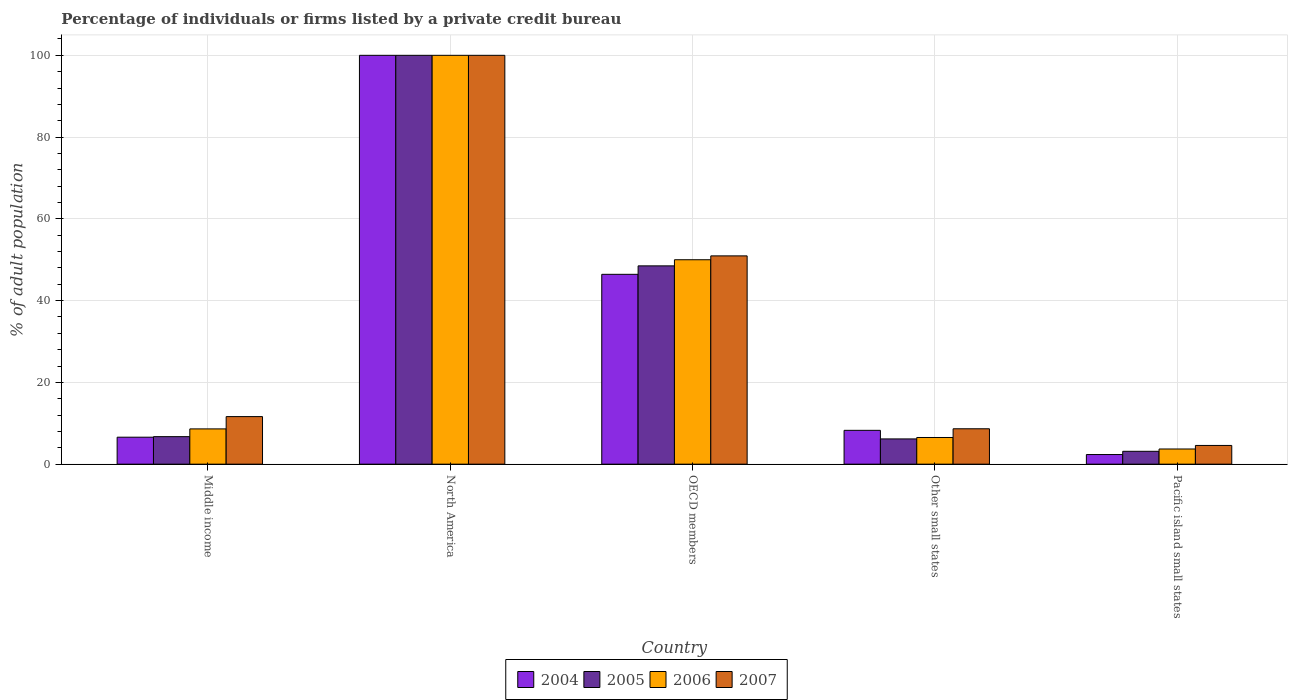How many bars are there on the 3rd tick from the right?
Provide a succinct answer. 4. What is the percentage of population listed by a private credit bureau in 2007 in OECD members?
Make the answer very short. 50.95. Across all countries, what is the maximum percentage of population listed by a private credit bureau in 2006?
Provide a succinct answer. 100. Across all countries, what is the minimum percentage of population listed by a private credit bureau in 2006?
Your answer should be compact. 3.71. In which country was the percentage of population listed by a private credit bureau in 2005 minimum?
Offer a terse response. Pacific island small states. What is the total percentage of population listed by a private credit bureau in 2004 in the graph?
Offer a very short reply. 163.66. What is the difference between the percentage of population listed by a private credit bureau in 2007 in OECD members and that in Other small states?
Your response must be concise. 42.29. What is the difference between the percentage of population listed by a private credit bureau in 2004 in Middle income and the percentage of population listed by a private credit bureau in 2007 in Other small states?
Provide a succinct answer. -2.06. What is the average percentage of population listed by a private credit bureau in 2005 per country?
Offer a very short reply. 32.91. What is the difference between the percentage of population listed by a private credit bureau of/in 2007 and percentage of population listed by a private credit bureau of/in 2004 in Pacific island small states?
Your answer should be very brief. 2.22. In how many countries, is the percentage of population listed by a private credit bureau in 2005 greater than 100 %?
Your answer should be very brief. 0. What is the ratio of the percentage of population listed by a private credit bureau in 2007 in Middle income to that in OECD members?
Provide a succinct answer. 0.23. Is the difference between the percentage of population listed by a private credit bureau in 2007 in North America and OECD members greater than the difference between the percentage of population listed by a private credit bureau in 2004 in North America and OECD members?
Your response must be concise. No. What is the difference between the highest and the second highest percentage of population listed by a private credit bureau in 2006?
Offer a terse response. -41.38. What is the difference between the highest and the lowest percentage of population listed by a private credit bureau in 2005?
Keep it short and to the point. 96.86. In how many countries, is the percentage of population listed by a private credit bureau in 2006 greater than the average percentage of population listed by a private credit bureau in 2006 taken over all countries?
Your answer should be compact. 2. How many countries are there in the graph?
Your answer should be compact. 5. What is the difference between two consecutive major ticks on the Y-axis?
Your response must be concise. 20. Where does the legend appear in the graph?
Your answer should be compact. Bottom center. What is the title of the graph?
Your answer should be compact. Percentage of individuals or firms listed by a private credit bureau. Does "2000" appear as one of the legend labels in the graph?
Provide a succinct answer. No. What is the label or title of the Y-axis?
Your answer should be very brief. % of adult population. What is the % of adult population in 2004 in Middle income?
Offer a terse response. 6.6. What is the % of adult population in 2005 in Middle income?
Offer a very short reply. 6.73. What is the % of adult population in 2006 in Middle income?
Keep it short and to the point. 8.62. What is the % of adult population of 2007 in Middle income?
Your answer should be very brief. 11.63. What is the % of adult population of 2004 in North America?
Your response must be concise. 100. What is the % of adult population of 2005 in North America?
Offer a terse response. 100. What is the % of adult population in 2007 in North America?
Provide a succinct answer. 100. What is the % of adult population of 2004 in OECD members?
Offer a terse response. 46.43. What is the % of adult population of 2005 in OECD members?
Offer a very short reply. 48.5. What is the % of adult population in 2007 in OECD members?
Provide a succinct answer. 50.95. What is the % of adult population of 2004 in Other small states?
Provide a short and direct response. 8.28. What is the % of adult population of 2005 in Other small states?
Give a very brief answer. 6.18. What is the % of adult population of 2006 in Other small states?
Ensure brevity in your answer.  6.52. What is the % of adult population of 2007 in Other small states?
Keep it short and to the point. 8.66. What is the % of adult population of 2004 in Pacific island small states?
Give a very brief answer. 2.36. What is the % of adult population of 2005 in Pacific island small states?
Give a very brief answer. 3.14. What is the % of adult population of 2006 in Pacific island small states?
Your answer should be very brief. 3.71. What is the % of adult population in 2007 in Pacific island small states?
Keep it short and to the point. 4.58. Across all countries, what is the maximum % of adult population of 2004?
Your answer should be very brief. 100. Across all countries, what is the maximum % of adult population of 2005?
Make the answer very short. 100. Across all countries, what is the minimum % of adult population in 2004?
Your response must be concise. 2.36. Across all countries, what is the minimum % of adult population of 2005?
Your answer should be compact. 3.14. Across all countries, what is the minimum % of adult population in 2006?
Your answer should be compact. 3.71. Across all countries, what is the minimum % of adult population of 2007?
Your answer should be very brief. 4.58. What is the total % of adult population of 2004 in the graph?
Your response must be concise. 163.66. What is the total % of adult population in 2005 in the graph?
Offer a very short reply. 164.55. What is the total % of adult population in 2006 in the graph?
Keep it short and to the point. 168.86. What is the total % of adult population of 2007 in the graph?
Your answer should be very brief. 175.81. What is the difference between the % of adult population in 2004 in Middle income and that in North America?
Make the answer very short. -93.4. What is the difference between the % of adult population in 2005 in Middle income and that in North America?
Provide a short and direct response. -93.27. What is the difference between the % of adult population of 2006 in Middle income and that in North America?
Your answer should be very brief. -91.38. What is the difference between the % of adult population in 2007 in Middle income and that in North America?
Make the answer very short. -88.37. What is the difference between the % of adult population in 2004 in Middle income and that in OECD members?
Give a very brief answer. -39.84. What is the difference between the % of adult population in 2005 in Middle income and that in OECD members?
Keep it short and to the point. -41.77. What is the difference between the % of adult population in 2006 in Middle income and that in OECD members?
Provide a short and direct response. -41.38. What is the difference between the % of adult population of 2007 in Middle income and that in OECD members?
Make the answer very short. -39.31. What is the difference between the % of adult population in 2004 in Middle income and that in Other small states?
Your answer should be very brief. -1.68. What is the difference between the % of adult population of 2005 in Middle income and that in Other small states?
Make the answer very short. 0.55. What is the difference between the % of adult population of 2006 in Middle income and that in Other small states?
Keep it short and to the point. 2.1. What is the difference between the % of adult population in 2007 in Middle income and that in Other small states?
Offer a terse response. 2.98. What is the difference between the % of adult population in 2004 in Middle income and that in Pacific island small states?
Provide a short and direct response. 4.24. What is the difference between the % of adult population of 2005 in Middle income and that in Pacific island small states?
Provide a succinct answer. 3.58. What is the difference between the % of adult population of 2006 in Middle income and that in Pacific island small states?
Offer a terse response. 4.91. What is the difference between the % of adult population in 2007 in Middle income and that in Pacific island small states?
Offer a terse response. 7.06. What is the difference between the % of adult population of 2004 in North America and that in OECD members?
Provide a short and direct response. 53.57. What is the difference between the % of adult population of 2005 in North America and that in OECD members?
Make the answer very short. 51.5. What is the difference between the % of adult population in 2006 in North America and that in OECD members?
Offer a terse response. 50. What is the difference between the % of adult population in 2007 in North America and that in OECD members?
Keep it short and to the point. 49.05. What is the difference between the % of adult population in 2004 in North America and that in Other small states?
Give a very brief answer. 91.72. What is the difference between the % of adult population in 2005 in North America and that in Other small states?
Offer a terse response. 93.82. What is the difference between the % of adult population of 2006 in North America and that in Other small states?
Ensure brevity in your answer.  93.48. What is the difference between the % of adult population of 2007 in North America and that in Other small states?
Ensure brevity in your answer.  91.34. What is the difference between the % of adult population of 2004 in North America and that in Pacific island small states?
Make the answer very short. 97.64. What is the difference between the % of adult population of 2005 in North America and that in Pacific island small states?
Your answer should be compact. 96.86. What is the difference between the % of adult population in 2006 in North America and that in Pacific island small states?
Your answer should be compact. 96.29. What is the difference between the % of adult population of 2007 in North America and that in Pacific island small states?
Make the answer very short. 95.42. What is the difference between the % of adult population in 2004 in OECD members and that in Other small states?
Your answer should be very brief. 38.16. What is the difference between the % of adult population in 2005 in OECD members and that in Other small states?
Your response must be concise. 42.33. What is the difference between the % of adult population of 2006 in OECD members and that in Other small states?
Offer a terse response. 43.48. What is the difference between the % of adult population of 2007 in OECD members and that in Other small states?
Your answer should be compact. 42.29. What is the difference between the % of adult population of 2004 in OECD members and that in Pacific island small states?
Offer a terse response. 44.08. What is the difference between the % of adult population of 2005 in OECD members and that in Pacific island small states?
Your answer should be compact. 45.36. What is the difference between the % of adult population of 2006 in OECD members and that in Pacific island small states?
Ensure brevity in your answer.  46.29. What is the difference between the % of adult population in 2007 in OECD members and that in Pacific island small states?
Keep it short and to the point. 46.37. What is the difference between the % of adult population in 2004 in Other small states and that in Pacific island small states?
Provide a succinct answer. 5.92. What is the difference between the % of adult population in 2005 in Other small states and that in Pacific island small states?
Keep it short and to the point. 3.03. What is the difference between the % of adult population of 2006 in Other small states and that in Pacific island small states?
Provide a succinct answer. 2.81. What is the difference between the % of adult population in 2007 in Other small states and that in Pacific island small states?
Make the answer very short. 4.08. What is the difference between the % of adult population of 2004 in Middle income and the % of adult population of 2005 in North America?
Make the answer very short. -93.4. What is the difference between the % of adult population of 2004 in Middle income and the % of adult population of 2006 in North America?
Provide a short and direct response. -93.4. What is the difference between the % of adult population of 2004 in Middle income and the % of adult population of 2007 in North America?
Your answer should be compact. -93.4. What is the difference between the % of adult population in 2005 in Middle income and the % of adult population in 2006 in North America?
Provide a succinct answer. -93.27. What is the difference between the % of adult population of 2005 in Middle income and the % of adult population of 2007 in North America?
Your answer should be very brief. -93.27. What is the difference between the % of adult population in 2006 in Middle income and the % of adult population in 2007 in North America?
Provide a succinct answer. -91.38. What is the difference between the % of adult population in 2004 in Middle income and the % of adult population in 2005 in OECD members?
Your answer should be very brief. -41.91. What is the difference between the % of adult population in 2004 in Middle income and the % of adult population in 2006 in OECD members?
Keep it short and to the point. -43.4. What is the difference between the % of adult population of 2004 in Middle income and the % of adult population of 2007 in OECD members?
Your answer should be very brief. -44.35. What is the difference between the % of adult population of 2005 in Middle income and the % of adult population of 2006 in OECD members?
Keep it short and to the point. -43.27. What is the difference between the % of adult population in 2005 in Middle income and the % of adult population in 2007 in OECD members?
Provide a short and direct response. -44.22. What is the difference between the % of adult population in 2006 in Middle income and the % of adult population in 2007 in OECD members?
Your response must be concise. -42.32. What is the difference between the % of adult population in 2004 in Middle income and the % of adult population in 2005 in Other small states?
Provide a succinct answer. 0.42. What is the difference between the % of adult population of 2004 in Middle income and the % of adult population of 2006 in Other small states?
Offer a terse response. 0.07. What is the difference between the % of adult population of 2004 in Middle income and the % of adult population of 2007 in Other small states?
Provide a short and direct response. -2.06. What is the difference between the % of adult population of 2005 in Middle income and the % of adult population of 2006 in Other small states?
Ensure brevity in your answer.  0.21. What is the difference between the % of adult population of 2005 in Middle income and the % of adult population of 2007 in Other small states?
Your answer should be compact. -1.93. What is the difference between the % of adult population of 2006 in Middle income and the % of adult population of 2007 in Other small states?
Offer a very short reply. -0.03. What is the difference between the % of adult population of 2004 in Middle income and the % of adult population of 2005 in Pacific island small states?
Your response must be concise. 3.45. What is the difference between the % of adult population in 2004 in Middle income and the % of adult population in 2006 in Pacific island small states?
Provide a succinct answer. 2.88. What is the difference between the % of adult population in 2004 in Middle income and the % of adult population in 2007 in Pacific island small states?
Provide a succinct answer. 2.02. What is the difference between the % of adult population in 2005 in Middle income and the % of adult population in 2006 in Pacific island small states?
Offer a terse response. 3.02. What is the difference between the % of adult population of 2005 in Middle income and the % of adult population of 2007 in Pacific island small states?
Provide a short and direct response. 2.15. What is the difference between the % of adult population in 2006 in Middle income and the % of adult population in 2007 in Pacific island small states?
Give a very brief answer. 4.05. What is the difference between the % of adult population of 2004 in North America and the % of adult population of 2005 in OECD members?
Your answer should be compact. 51.5. What is the difference between the % of adult population in 2004 in North America and the % of adult population in 2006 in OECD members?
Your answer should be compact. 50. What is the difference between the % of adult population of 2004 in North America and the % of adult population of 2007 in OECD members?
Provide a succinct answer. 49.05. What is the difference between the % of adult population in 2005 in North America and the % of adult population in 2006 in OECD members?
Make the answer very short. 50. What is the difference between the % of adult population of 2005 in North America and the % of adult population of 2007 in OECD members?
Your response must be concise. 49.05. What is the difference between the % of adult population in 2006 in North America and the % of adult population in 2007 in OECD members?
Ensure brevity in your answer.  49.05. What is the difference between the % of adult population in 2004 in North America and the % of adult population in 2005 in Other small states?
Provide a short and direct response. 93.82. What is the difference between the % of adult population of 2004 in North America and the % of adult population of 2006 in Other small states?
Offer a terse response. 93.48. What is the difference between the % of adult population in 2004 in North America and the % of adult population in 2007 in Other small states?
Your answer should be very brief. 91.34. What is the difference between the % of adult population in 2005 in North America and the % of adult population in 2006 in Other small states?
Keep it short and to the point. 93.48. What is the difference between the % of adult population in 2005 in North America and the % of adult population in 2007 in Other small states?
Keep it short and to the point. 91.34. What is the difference between the % of adult population in 2006 in North America and the % of adult population in 2007 in Other small states?
Your answer should be very brief. 91.34. What is the difference between the % of adult population in 2004 in North America and the % of adult population in 2005 in Pacific island small states?
Make the answer very short. 96.86. What is the difference between the % of adult population in 2004 in North America and the % of adult population in 2006 in Pacific island small states?
Your answer should be very brief. 96.29. What is the difference between the % of adult population in 2004 in North America and the % of adult population in 2007 in Pacific island small states?
Your answer should be compact. 95.42. What is the difference between the % of adult population of 2005 in North America and the % of adult population of 2006 in Pacific island small states?
Your answer should be compact. 96.29. What is the difference between the % of adult population of 2005 in North America and the % of adult population of 2007 in Pacific island small states?
Provide a short and direct response. 95.42. What is the difference between the % of adult population of 2006 in North America and the % of adult population of 2007 in Pacific island small states?
Offer a terse response. 95.42. What is the difference between the % of adult population in 2004 in OECD members and the % of adult population in 2005 in Other small states?
Your answer should be compact. 40.26. What is the difference between the % of adult population of 2004 in OECD members and the % of adult population of 2006 in Other small states?
Offer a terse response. 39.91. What is the difference between the % of adult population in 2004 in OECD members and the % of adult population in 2007 in Other small states?
Ensure brevity in your answer.  37.78. What is the difference between the % of adult population in 2005 in OECD members and the % of adult population in 2006 in Other small states?
Your answer should be compact. 41.98. What is the difference between the % of adult population of 2005 in OECD members and the % of adult population of 2007 in Other small states?
Offer a terse response. 39.85. What is the difference between the % of adult population of 2006 in OECD members and the % of adult population of 2007 in Other small states?
Offer a very short reply. 41.34. What is the difference between the % of adult population in 2004 in OECD members and the % of adult population in 2005 in Pacific island small states?
Give a very brief answer. 43.29. What is the difference between the % of adult population in 2004 in OECD members and the % of adult population in 2006 in Pacific island small states?
Ensure brevity in your answer.  42.72. What is the difference between the % of adult population of 2004 in OECD members and the % of adult population of 2007 in Pacific island small states?
Provide a succinct answer. 41.86. What is the difference between the % of adult population of 2005 in OECD members and the % of adult population of 2006 in Pacific island small states?
Keep it short and to the point. 44.79. What is the difference between the % of adult population in 2005 in OECD members and the % of adult population in 2007 in Pacific island small states?
Make the answer very short. 43.93. What is the difference between the % of adult population in 2006 in OECD members and the % of adult population in 2007 in Pacific island small states?
Your response must be concise. 45.42. What is the difference between the % of adult population in 2004 in Other small states and the % of adult population in 2005 in Pacific island small states?
Provide a succinct answer. 5.13. What is the difference between the % of adult population of 2004 in Other small states and the % of adult population of 2006 in Pacific island small states?
Keep it short and to the point. 4.56. What is the difference between the % of adult population of 2004 in Other small states and the % of adult population of 2007 in Pacific island small states?
Offer a very short reply. 3.7. What is the difference between the % of adult population of 2005 in Other small states and the % of adult population of 2006 in Pacific island small states?
Provide a succinct answer. 2.47. What is the difference between the % of adult population of 2005 in Other small states and the % of adult population of 2007 in Pacific island small states?
Provide a short and direct response. 1.6. What is the difference between the % of adult population of 2006 in Other small states and the % of adult population of 2007 in Pacific island small states?
Ensure brevity in your answer.  1.94. What is the average % of adult population of 2004 per country?
Your answer should be compact. 32.73. What is the average % of adult population of 2005 per country?
Your answer should be very brief. 32.91. What is the average % of adult population of 2006 per country?
Your answer should be compact. 33.77. What is the average % of adult population in 2007 per country?
Offer a very short reply. 35.16. What is the difference between the % of adult population in 2004 and % of adult population in 2005 in Middle income?
Make the answer very short. -0.13. What is the difference between the % of adult population in 2004 and % of adult population in 2006 in Middle income?
Ensure brevity in your answer.  -2.03. What is the difference between the % of adult population of 2004 and % of adult population of 2007 in Middle income?
Make the answer very short. -5.04. What is the difference between the % of adult population of 2005 and % of adult population of 2006 in Middle income?
Offer a very short reply. -1.9. What is the difference between the % of adult population of 2005 and % of adult population of 2007 in Middle income?
Your answer should be compact. -4.91. What is the difference between the % of adult population in 2006 and % of adult population in 2007 in Middle income?
Make the answer very short. -3.01. What is the difference between the % of adult population in 2005 and % of adult population in 2006 in North America?
Your response must be concise. 0. What is the difference between the % of adult population of 2005 and % of adult population of 2007 in North America?
Ensure brevity in your answer.  0. What is the difference between the % of adult population in 2004 and % of adult population in 2005 in OECD members?
Your answer should be very brief. -2.07. What is the difference between the % of adult population of 2004 and % of adult population of 2006 in OECD members?
Ensure brevity in your answer.  -3.57. What is the difference between the % of adult population in 2004 and % of adult population in 2007 in OECD members?
Keep it short and to the point. -4.51. What is the difference between the % of adult population in 2005 and % of adult population in 2006 in OECD members?
Your answer should be very brief. -1.5. What is the difference between the % of adult population of 2005 and % of adult population of 2007 in OECD members?
Keep it short and to the point. -2.44. What is the difference between the % of adult population of 2006 and % of adult population of 2007 in OECD members?
Your answer should be compact. -0.95. What is the difference between the % of adult population of 2004 and % of adult population of 2005 in Other small states?
Your response must be concise. 2.1. What is the difference between the % of adult population of 2004 and % of adult population of 2006 in Other small states?
Keep it short and to the point. 1.75. What is the difference between the % of adult population of 2004 and % of adult population of 2007 in Other small states?
Offer a very short reply. -0.38. What is the difference between the % of adult population of 2005 and % of adult population of 2006 in Other small states?
Ensure brevity in your answer.  -0.35. What is the difference between the % of adult population in 2005 and % of adult population in 2007 in Other small states?
Offer a terse response. -2.48. What is the difference between the % of adult population of 2006 and % of adult population of 2007 in Other small states?
Keep it short and to the point. -2.13. What is the difference between the % of adult population of 2004 and % of adult population of 2005 in Pacific island small states?
Make the answer very short. -0.79. What is the difference between the % of adult population of 2004 and % of adult population of 2006 in Pacific island small states?
Your answer should be very brief. -1.36. What is the difference between the % of adult population of 2004 and % of adult population of 2007 in Pacific island small states?
Ensure brevity in your answer.  -2.22. What is the difference between the % of adult population of 2005 and % of adult population of 2006 in Pacific island small states?
Ensure brevity in your answer.  -0.57. What is the difference between the % of adult population of 2005 and % of adult population of 2007 in Pacific island small states?
Provide a short and direct response. -1.43. What is the difference between the % of adult population of 2006 and % of adult population of 2007 in Pacific island small states?
Ensure brevity in your answer.  -0.87. What is the ratio of the % of adult population of 2004 in Middle income to that in North America?
Ensure brevity in your answer.  0.07. What is the ratio of the % of adult population in 2005 in Middle income to that in North America?
Provide a short and direct response. 0.07. What is the ratio of the % of adult population of 2006 in Middle income to that in North America?
Provide a succinct answer. 0.09. What is the ratio of the % of adult population in 2007 in Middle income to that in North America?
Give a very brief answer. 0.12. What is the ratio of the % of adult population in 2004 in Middle income to that in OECD members?
Provide a succinct answer. 0.14. What is the ratio of the % of adult population of 2005 in Middle income to that in OECD members?
Your answer should be compact. 0.14. What is the ratio of the % of adult population in 2006 in Middle income to that in OECD members?
Your answer should be compact. 0.17. What is the ratio of the % of adult population in 2007 in Middle income to that in OECD members?
Your answer should be compact. 0.23. What is the ratio of the % of adult population of 2004 in Middle income to that in Other small states?
Keep it short and to the point. 0.8. What is the ratio of the % of adult population in 2005 in Middle income to that in Other small states?
Your answer should be very brief. 1.09. What is the ratio of the % of adult population of 2006 in Middle income to that in Other small states?
Ensure brevity in your answer.  1.32. What is the ratio of the % of adult population in 2007 in Middle income to that in Other small states?
Keep it short and to the point. 1.34. What is the ratio of the % of adult population in 2004 in Middle income to that in Pacific island small states?
Your answer should be very brief. 2.8. What is the ratio of the % of adult population of 2005 in Middle income to that in Pacific island small states?
Make the answer very short. 2.14. What is the ratio of the % of adult population of 2006 in Middle income to that in Pacific island small states?
Make the answer very short. 2.32. What is the ratio of the % of adult population in 2007 in Middle income to that in Pacific island small states?
Offer a very short reply. 2.54. What is the ratio of the % of adult population of 2004 in North America to that in OECD members?
Give a very brief answer. 2.15. What is the ratio of the % of adult population of 2005 in North America to that in OECD members?
Ensure brevity in your answer.  2.06. What is the ratio of the % of adult population in 2007 in North America to that in OECD members?
Offer a terse response. 1.96. What is the ratio of the % of adult population in 2004 in North America to that in Other small states?
Offer a very short reply. 12.08. What is the ratio of the % of adult population in 2005 in North America to that in Other small states?
Make the answer very short. 16.19. What is the ratio of the % of adult population of 2006 in North America to that in Other small states?
Provide a short and direct response. 15.33. What is the ratio of the % of adult population of 2007 in North America to that in Other small states?
Make the answer very short. 11.55. What is the ratio of the % of adult population in 2004 in North America to that in Pacific island small states?
Provide a succinct answer. 42.45. What is the ratio of the % of adult population in 2005 in North America to that in Pacific island small states?
Offer a very short reply. 31.8. What is the ratio of the % of adult population in 2006 in North America to that in Pacific island small states?
Offer a terse response. 26.95. What is the ratio of the % of adult population in 2007 in North America to that in Pacific island small states?
Provide a succinct answer. 21.84. What is the ratio of the % of adult population of 2004 in OECD members to that in Other small states?
Your answer should be compact. 5.61. What is the ratio of the % of adult population of 2005 in OECD members to that in Other small states?
Your response must be concise. 7.85. What is the ratio of the % of adult population in 2006 in OECD members to that in Other small states?
Your answer should be very brief. 7.67. What is the ratio of the % of adult population in 2007 in OECD members to that in Other small states?
Offer a very short reply. 5.89. What is the ratio of the % of adult population in 2004 in OECD members to that in Pacific island small states?
Provide a succinct answer. 19.71. What is the ratio of the % of adult population of 2005 in OECD members to that in Pacific island small states?
Provide a succinct answer. 15.43. What is the ratio of the % of adult population in 2006 in OECD members to that in Pacific island small states?
Give a very brief answer. 13.47. What is the ratio of the % of adult population in 2007 in OECD members to that in Pacific island small states?
Ensure brevity in your answer.  11.13. What is the ratio of the % of adult population of 2004 in Other small states to that in Pacific island small states?
Offer a terse response. 3.51. What is the ratio of the % of adult population in 2005 in Other small states to that in Pacific island small states?
Your answer should be compact. 1.96. What is the ratio of the % of adult population in 2006 in Other small states to that in Pacific island small states?
Keep it short and to the point. 1.76. What is the ratio of the % of adult population of 2007 in Other small states to that in Pacific island small states?
Offer a terse response. 1.89. What is the difference between the highest and the second highest % of adult population in 2004?
Keep it short and to the point. 53.57. What is the difference between the highest and the second highest % of adult population of 2005?
Offer a very short reply. 51.5. What is the difference between the highest and the second highest % of adult population in 2007?
Keep it short and to the point. 49.05. What is the difference between the highest and the lowest % of adult population of 2004?
Ensure brevity in your answer.  97.64. What is the difference between the highest and the lowest % of adult population of 2005?
Give a very brief answer. 96.86. What is the difference between the highest and the lowest % of adult population in 2006?
Offer a terse response. 96.29. What is the difference between the highest and the lowest % of adult population in 2007?
Provide a short and direct response. 95.42. 